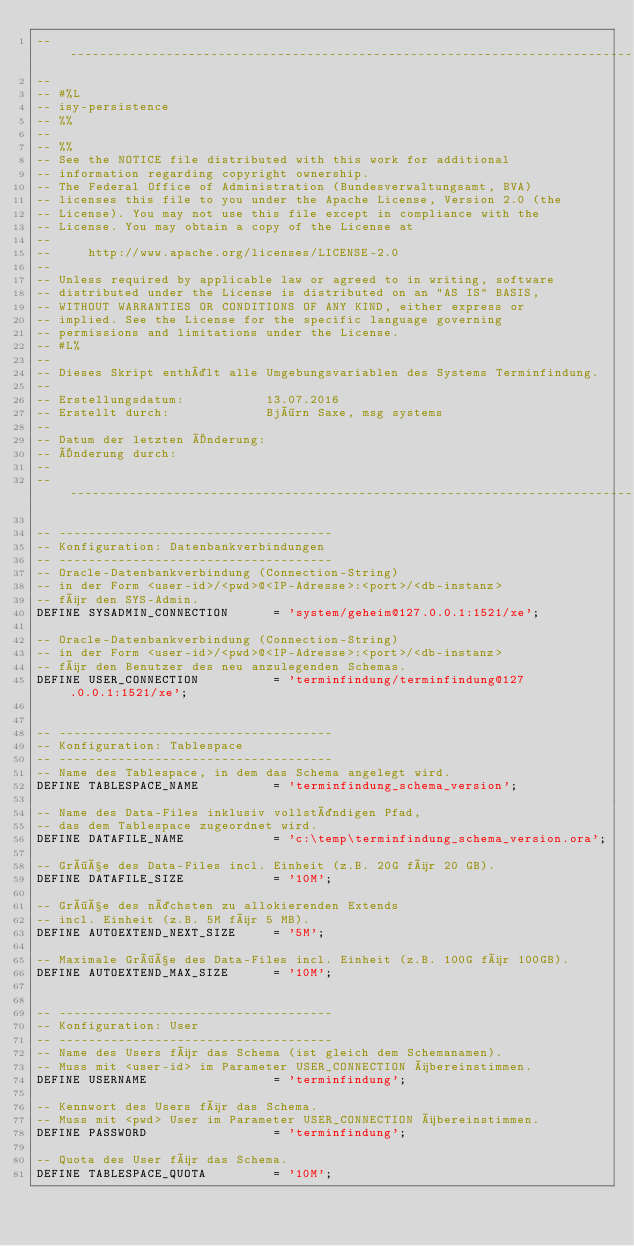<code> <loc_0><loc_0><loc_500><loc_500><_SQL_>-- -----------------------------------------------------------------------------------------------------
--
-- #%L
-- isy-persistence
-- %%
-- 
-- %%
-- See the NOTICE file distributed with this work for additional
-- information regarding copyright ownership.
-- The Federal Office of Administration (Bundesverwaltungsamt, BVA)
-- licenses this file to you under the Apache License, Version 2.0 (the
-- License). You may not use this file except in compliance with the
-- License. You may obtain a copy of the License at
-- 
--     http://www.apache.org/licenses/LICENSE-2.0
-- 
-- Unless required by applicable law or agreed to in writing, software
-- distributed under the License is distributed on an "AS IS" BASIS,
-- WITHOUT WARRANTIES OR CONDITIONS OF ANY KIND, either express or
-- implied. See the License for the specific language governing
-- permissions and limitations under the License.
-- #L%
--
-- Dieses Skript enthält alle Umgebungsvariablen des Systems Terminfindung.
-- 
-- Erstellungsdatum:           13.07.2016
-- Erstellt durch:             Björn Saxe, msg systems
-- 
-- Datum der letzten Änderung: 
-- Änderung durch:             
--
-- -----------------------------------------------------------------------------------------------------

-- -------------------------------------
-- Konfiguration: Datenbankverbindungen
-- -------------------------------------
-- Oracle-Datenbankverbindung (Connection-String) 
-- in der Form <user-id>/<pwd>@<IP-Adresse>:<port>/<db-instanz>
-- für den SYS-Admin.
DEFINE SYSADMIN_CONNECTION      = 'system/geheim@127.0.0.1:1521/xe';

-- Oracle-Datenbankverbindung (Connection-String) 
-- in der Form <user-id>/<pwd>@<IP-Adresse>:<port>/<db-instanz>
-- für den Benutzer des neu anzulegenden Schemas.
DEFINE USER_CONNECTION          = 'terminfindung/terminfindung@127.0.0.1:1521/xe';


-- -------------------------------------
-- Konfiguration: Tablespace
-- -------------------------------------
-- Name des Tablespace, in dem das Schema angelegt wird.
DEFINE TABLESPACE_NAME          = 'terminfindung_schema_version';

-- Name des Data-Files inklusiv vollständigen Pfad, 
-- das dem Tablespace zugeordnet wird.
DEFINE DATAFILE_NAME            = 'c:\temp\terminfindung_schema_version.ora';

-- Größe des Data-Files incl. Einheit (z.B. 20G für 20 GB).
DEFINE DATAFILE_SIZE            = '10M';

-- Größe des nächsten zu allokierenden Extends 
-- incl. Einheit (z.B. 5M für 5 MB).
DEFINE AUTOEXTEND_NEXT_SIZE     = '5M'; 

-- Maximale Größe des Data-Files incl. Einheit (z.B. 100G für 100GB).
DEFINE AUTOEXTEND_MAX_SIZE      = '10M';


-- -------------------------------------
-- Konfiguration: User
-- -------------------------------------
-- Name des Users für das Schema (ist gleich dem Schemanamen). 
-- Muss mit <user-id> im Parameter USER_CONNECTION übereinstimmen.
DEFINE USERNAME                 = 'terminfindung';

-- Kennwort des Users für das Schema. 
-- Muss mit <pwd> User im Parameter USER_CONNECTION übereinstimmen.
DEFINE PASSWORD                 = 'terminfindung';

-- Quota des User für das Schema.
DEFINE TABLESPACE_QUOTA         = '10M';
</code> 